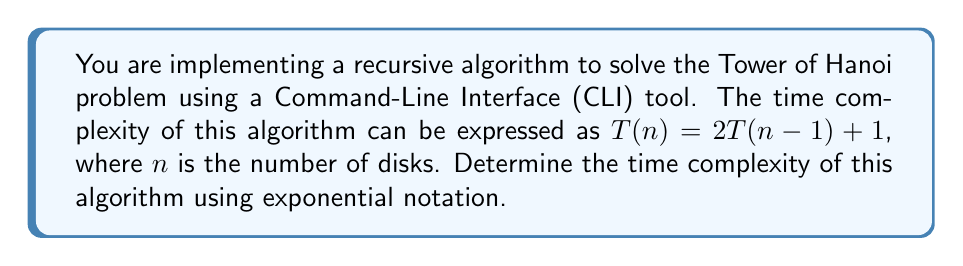Provide a solution to this math problem. Let's solve this step-by-step:

1) We start with the recurrence relation: $T(n) = 2T(n-1) + 1$

2) Let's expand this relation:
   $T(n) = 2(2T(n-2) + 1) + 1$
         $= 2^2T(n-2) + 2 + 1$
         $= 2^2T(n-2) + 3$

3) Expanding further:
   $T(n) = 2^2(2T(n-3) + 1) + 3$
         $= 2^3T(n-3) + 2^2 + 3$
         $= 2^3T(n-3) + 7$

4) We can see a pattern forming. After $k$ expansions:
   $T(n) = 2^kT(n-k) + (2^k - 1)$

5) When $k = n$, we reach the base case $T(0) = 1$:
   $T(n) = 2^nT(0) + (2^n - 1)$
         $= 2^n + 2^n - 1$
         $= 2^{n+1} - 1$

6) In Big O notation, we ignore constants and lower-order terms:
   $T(n) = O(2^n)$

Therefore, the time complexity of the algorithm is exponential, specifically $O(2^n)$.
Answer: $O(2^n)$ 